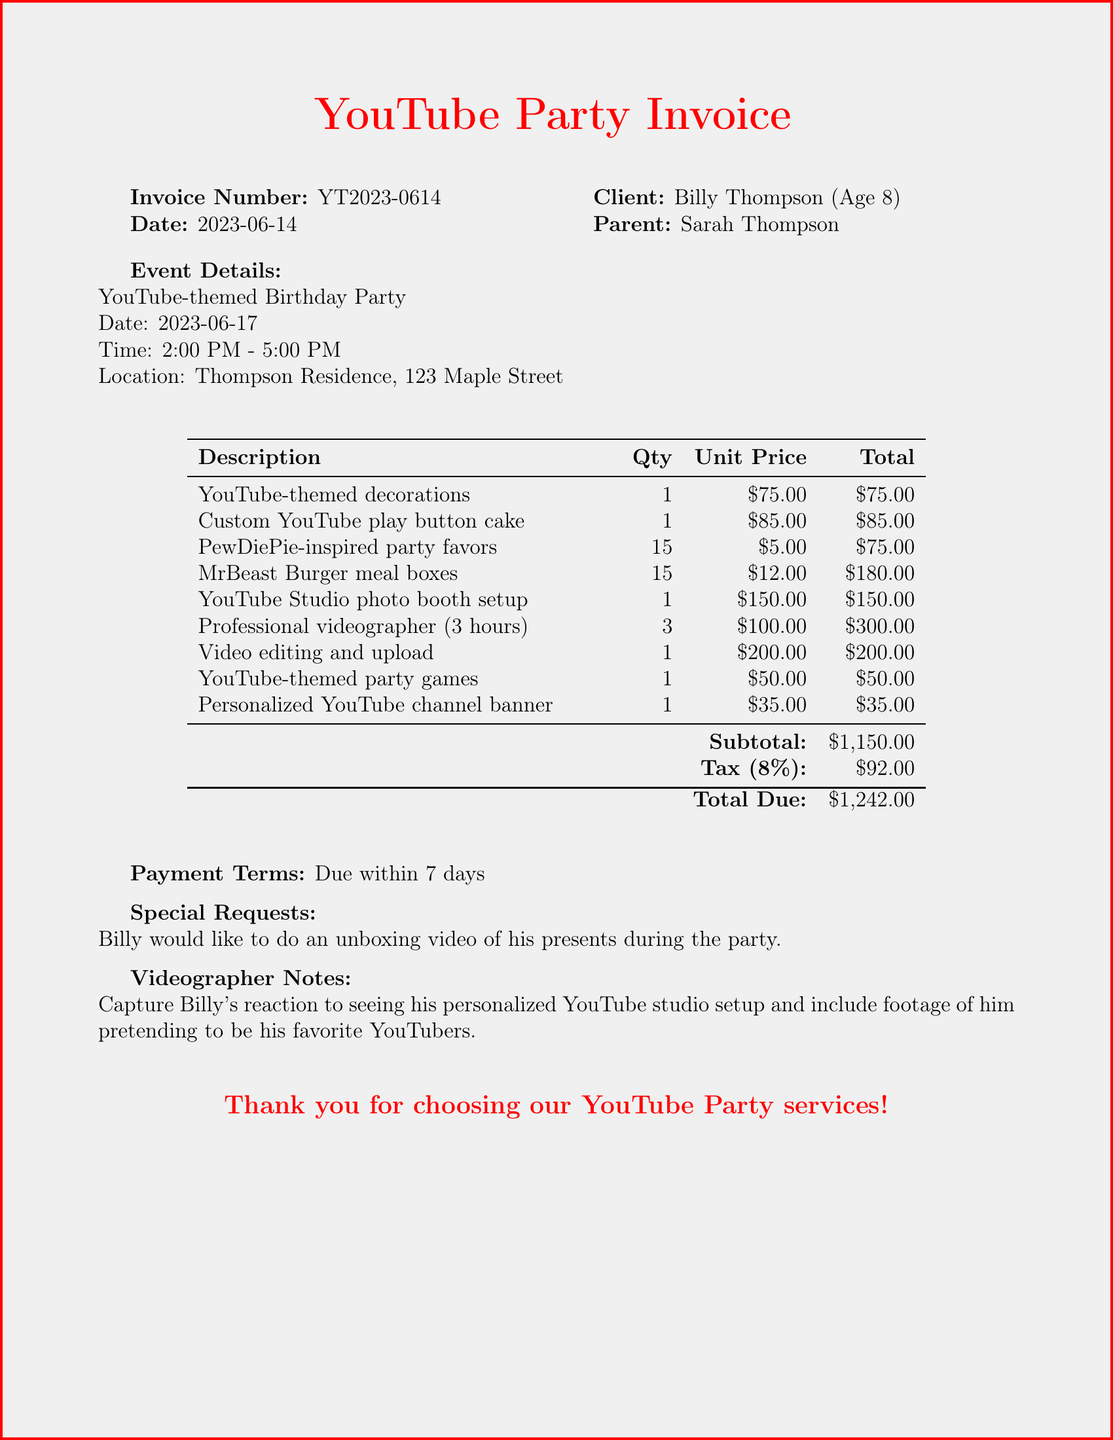What is the invoice number? The invoice number is a specific identifier for this transaction, which is indicated in the document.
Answer: YT2023-0614 What date is the party scheduled for? The date of the party is listed under the event details section of the document.
Answer: 2023-06-17 How much is the professional videographer's fee? The videographer's fee can be found under the items section, where the specific charge is detailed.
Answer: 300.00 What is the total amount due? The total due is the final amount payable as indicated at the bottom of the invoice.
Answer: 1242.00 How many party favors are there? The quantity of party favors is stated in the items section, specifying how many are provided.
Answer: 15 What special request did Billy make? The special request is noted in the document, which indicates Billy's desire for an activity during the party.
Answer: Unboxing video What is included in the videographer notes? The videographer notes detail specific instructions for capturing moments during the event.
Answer: Capture Billy's reaction What is the subtotal of the invoice? The subtotal represents the sum of the itemized costs before tax is applied, listed in the document.
Answer: 1150.00 What is the tax rate applied to the invoice? The tax rate is mentioned in the document and is associated with the calculation of the tax amount.
Answer: 0.08 